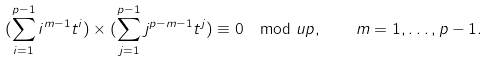<formula> <loc_0><loc_0><loc_500><loc_500>( \sum _ { i = 1 } ^ { p - 1 } i ^ { m - 1 } t ^ { i } ) \times ( \sum _ { j = 1 } ^ { p - 1 } j ^ { p - m - 1 } t ^ { j } ) \equiv 0 \mod u p , \quad m = 1 , \dots , p - 1 .</formula> 